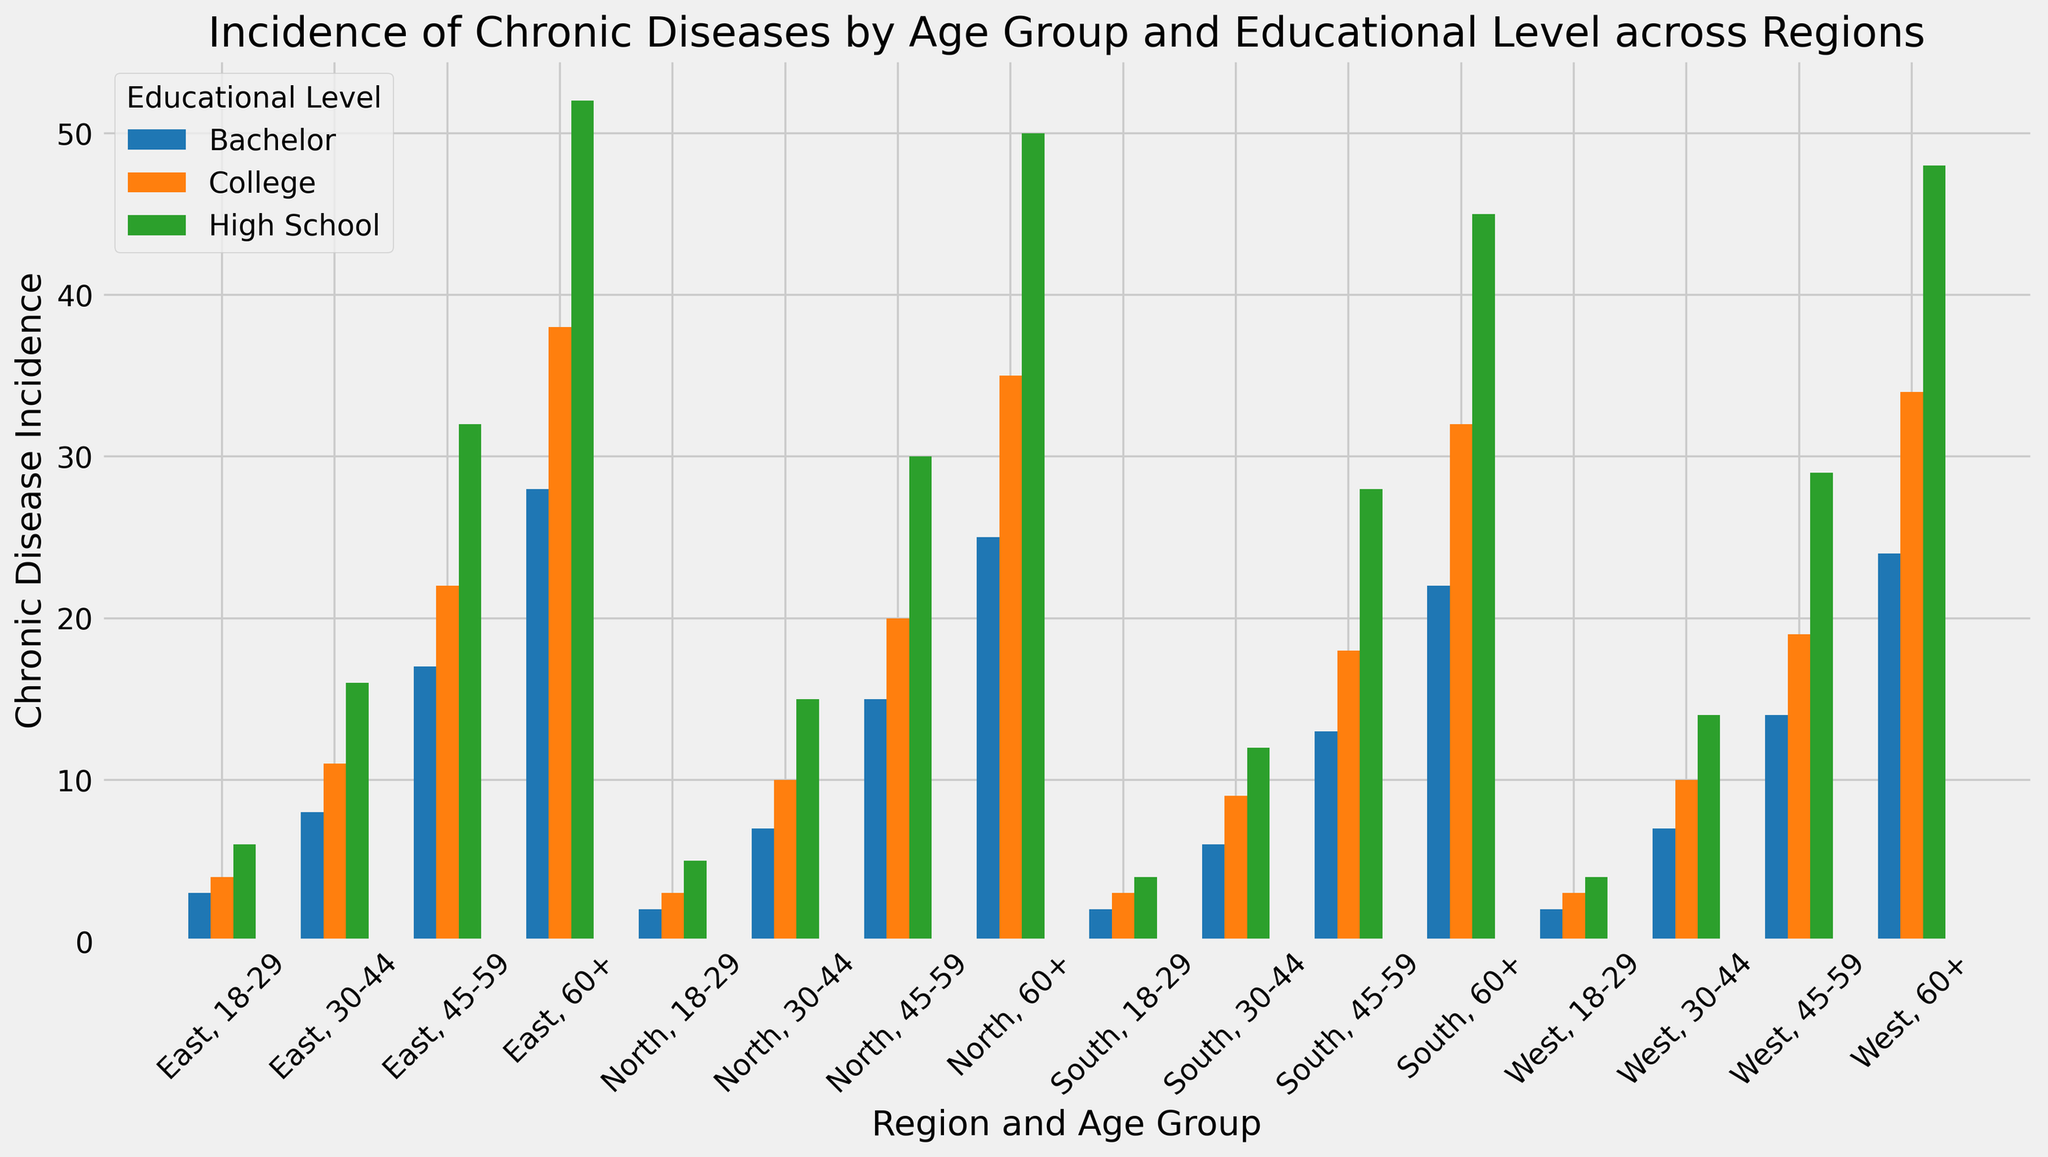Which region has the highest incidence of chronic diseases for the age group 60+ with a Bachelor's degree? The visual representation of the bars for people aged 60+ with a Bachelor's degree will indicate the highest value. By comparing the bars of the North, South, East, and West regions, the East region stands out as having the highest bar among them.
Answer: East region Comparing the age groups 30-44 and 45-59 with a Bachelor's degree, which group has a higher average incidence of chronic diseases across all regions? For each region, add the incidences for the 30-44 and 45-59 age groups with a Bachelor's degree, then calculate the average for both groups. North: (7+15)/2; South: (6+13)/2; East: (8+17)/2; West: (7+14)/2. Compare the resulting averages.
Answer: Age group 45-59 Which educational level has the tallest bars in the plot? Visually inspect the plot to see which educational level consistently has the highest bars across different age groups and regions. The educational level with the tallest bars indicates the highest incidence.
Answer: High School What is the total incidence of chronic diseases for people aged 18-29 across all regions? Sum the incidences for the age group 18-29 across the North, South, East, and West regions for each educational level. (5+3+2) + (4+3+2) + (6+4+3) + (4+3+2).
Answer: 41 Is the incidence of chronic diseases higher in the North or the South for people aged 60+ with a College degree? Compare the bar heights representing the incidence of chronic diseases for people aged 60+ with a College degree between the North and South regions. The North has a bar height of 35, while the South has a bar height of 32.
Answer: North 